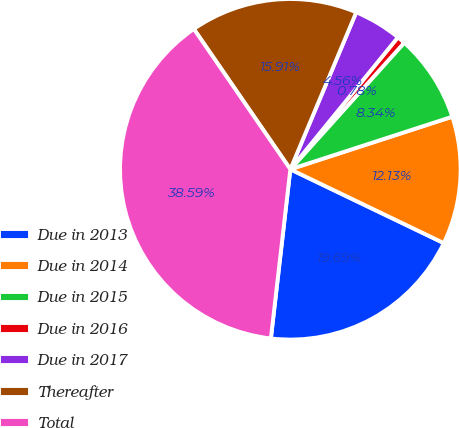Convert chart to OTSL. <chart><loc_0><loc_0><loc_500><loc_500><pie_chart><fcel>Due in 2013<fcel>Due in 2014<fcel>Due in 2015<fcel>Due in 2016<fcel>Due in 2017<fcel>Thereafter<fcel>Total<nl><fcel>19.69%<fcel>12.13%<fcel>8.34%<fcel>0.78%<fcel>4.56%<fcel>15.91%<fcel>38.59%<nl></chart> 